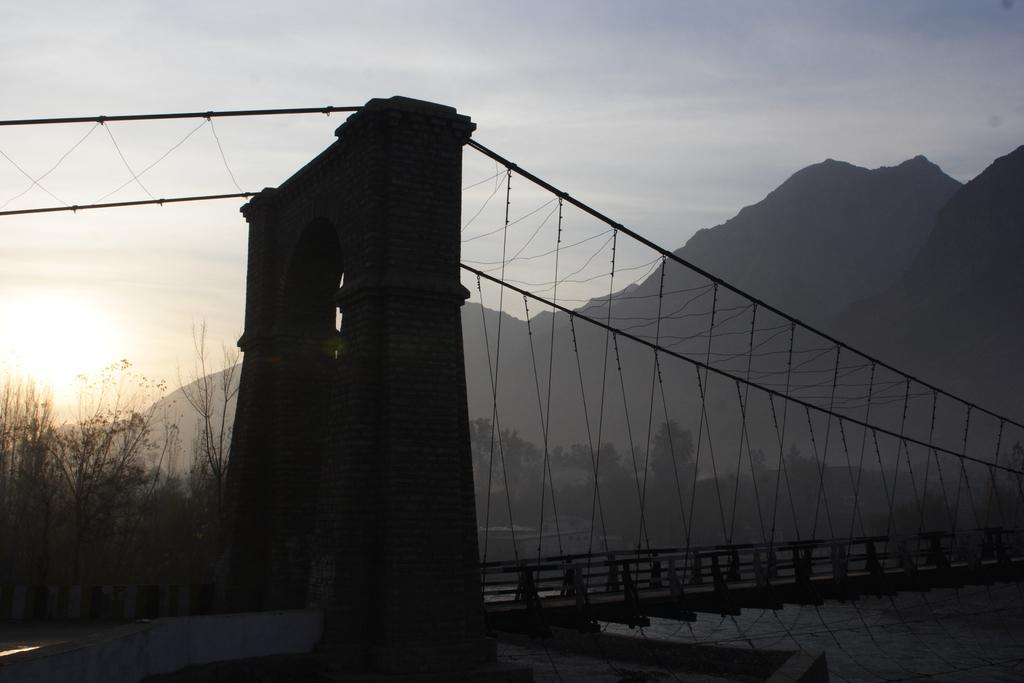What type of bridge is shown in the image? There is a rope bridge in the image. What is the bridge positioned above? The rope bridge is positioned above water. What can be seen on the other side of the bridge? There are trees and mountains on the other side of the bridge. How many toes are visible on the rope bridge in the image? There are no toes visible on the rope bridge in the image. What type of boats can be seen navigating the water beneath the bridge? There are no boats visible in the image; it only shows the rope bridge and the surrounding landscape. 